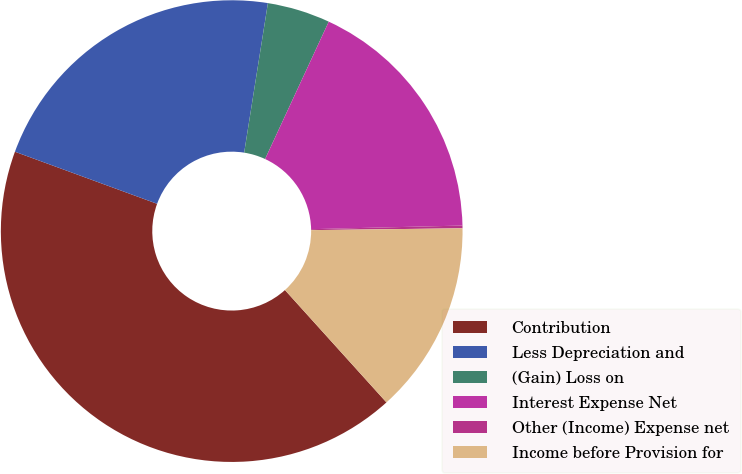Convert chart to OTSL. <chart><loc_0><loc_0><loc_500><loc_500><pie_chart><fcel>Contribution<fcel>Less Depreciation and<fcel>(Gain) Loss on<fcel>Interest Expense Net<fcel>Other (Income) Expense net<fcel>Income before Provision for<nl><fcel>42.28%<fcel>21.92%<fcel>4.4%<fcel>17.71%<fcel>0.19%<fcel>13.5%<nl></chart> 